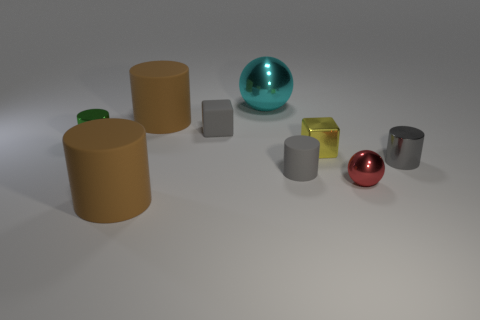Are there any metallic things that have the same color as the small rubber cube?
Provide a short and direct response. Yes. Is the size of the yellow object the same as the green metal cylinder that is to the left of the red shiny thing?
Offer a terse response. Yes. How many small cubes are on the right side of the ball that is in front of the gray matte object that is on the right side of the cyan object?
Give a very brief answer. 0. What size is the metallic object that is the same color as the rubber block?
Your answer should be compact. Small. There is a small metallic sphere; are there any brown matte cylinders behind it?
Provide a succinct answer. Yes. There is a tiny yellow metallic object; what shape is it?
Make the answer very short. Cube. What shape is the big brown matte thing that is right of the brown cylinder in front of the small gray matte cylinder on the right side of the large cyan metallic sphere?
Offer a terse response. Cylinder. How many other objects are the same shape as the big cyan thing?
Ensure brevity in your answer.  1. What material is the large brown cylinder behind the big brown object in front of the tiny green cylinder made of?
Give a very brief answer. Rubber. Is the small sphere made of the same material as the big cylinder behind the tiny red sphere?
Give a very brief answer. No. 